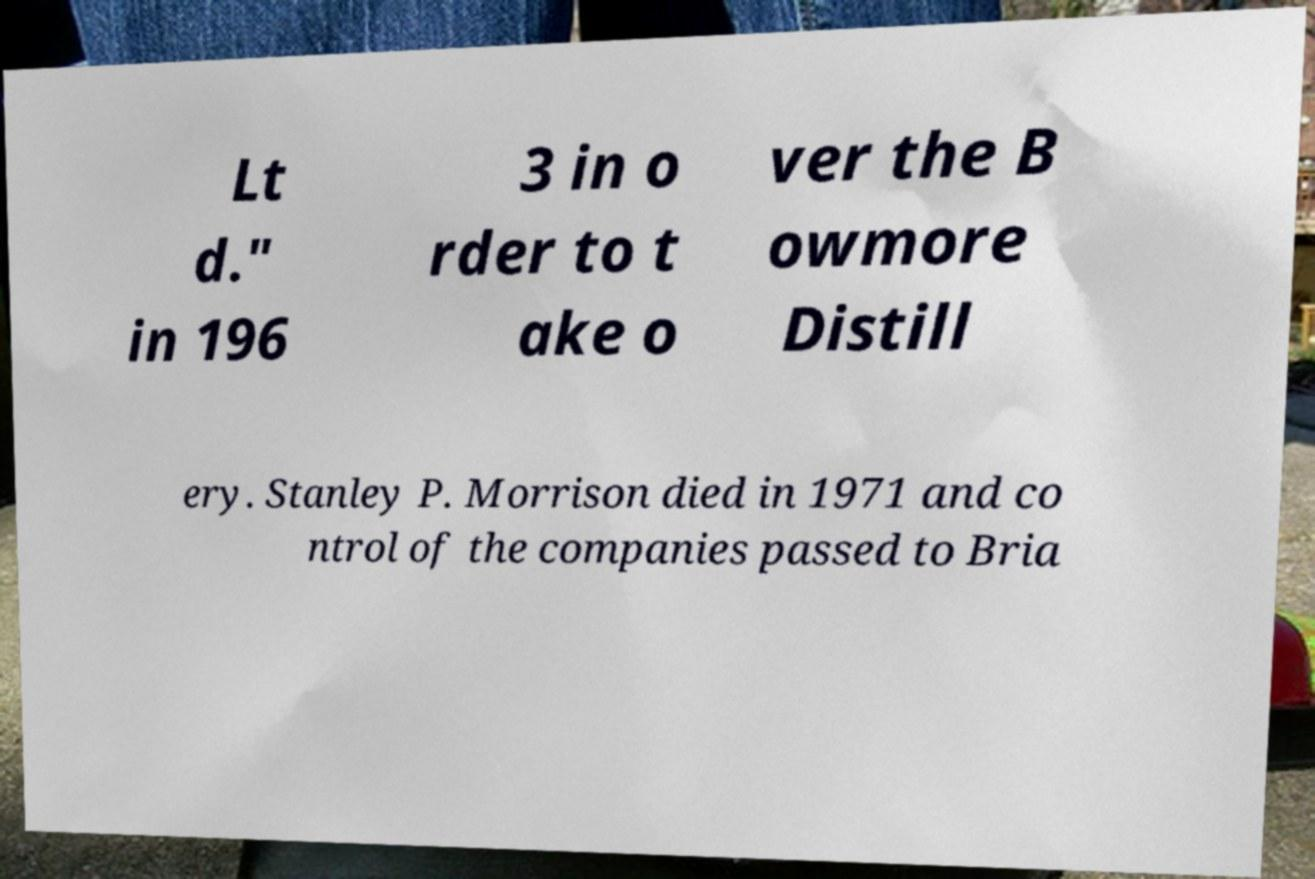Please identify and transcribe the text found in this image. Lt d." in 196 3 in o rder to t ake o ver the B owmore Distill ery. Stanley P. Morrison died in 1971 and co ntrol of the companies passed to Bria 